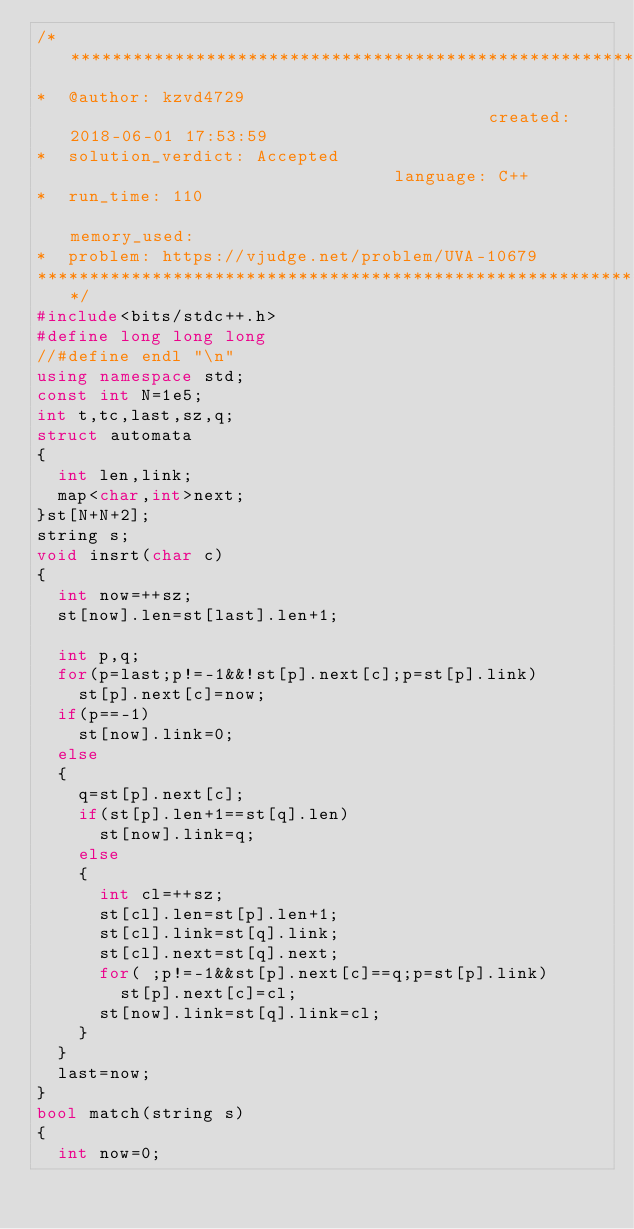<code> <loc_0><loc_0><loc_500><loc_500><_C++_>/****************************************************************************************
*  @author: kzvd4729                                         created: 2018-06-01 17:53:59                      
*  solution_verdict: Accepted                                language: C++                                     
*  run_time: 110                                             memory_used:                                      
*  problem: https://vjudge.net/problem/UVA-10679
****************************************************************************************/
#include<bits/stdc++.h>
#define long long long
//#define endl "\n"
using namespace std;
const int N=1e5;
int t,tc,last,sz,q;
struct automata
{
  int len,link;
  map<char,int>next;
}st[N+N+2];
string s;
void insrt(char c)
{
  int now=++sz;
  st[now].len=st[last].len+1;

  int p,q;
  for(p=last;p!=-1&&!st[p].next[c];p=st[p].link)
    st[p].next[c]=now;
  if(p==-1)
    st[now].link=0;
  else
  {
    q=st[p].next[c];
    if(st[p].len+1==st[q].len)
      st[now].link=q;
    else
    {
      int cl=++sz;
      st[cl].len=st[p].len+1;
      st[cl].link=st[q].link;
      st[cl].next=st[q].next;
      for( ;p!=-1&&st[p].next[c]==q;p=st[p].link)
        st[p].next[c]=cl;
      st[now].link=st[q].link=cl;
    }
  }
  last=now;
}
bool match(string s)
{
  int now=0;</code> 